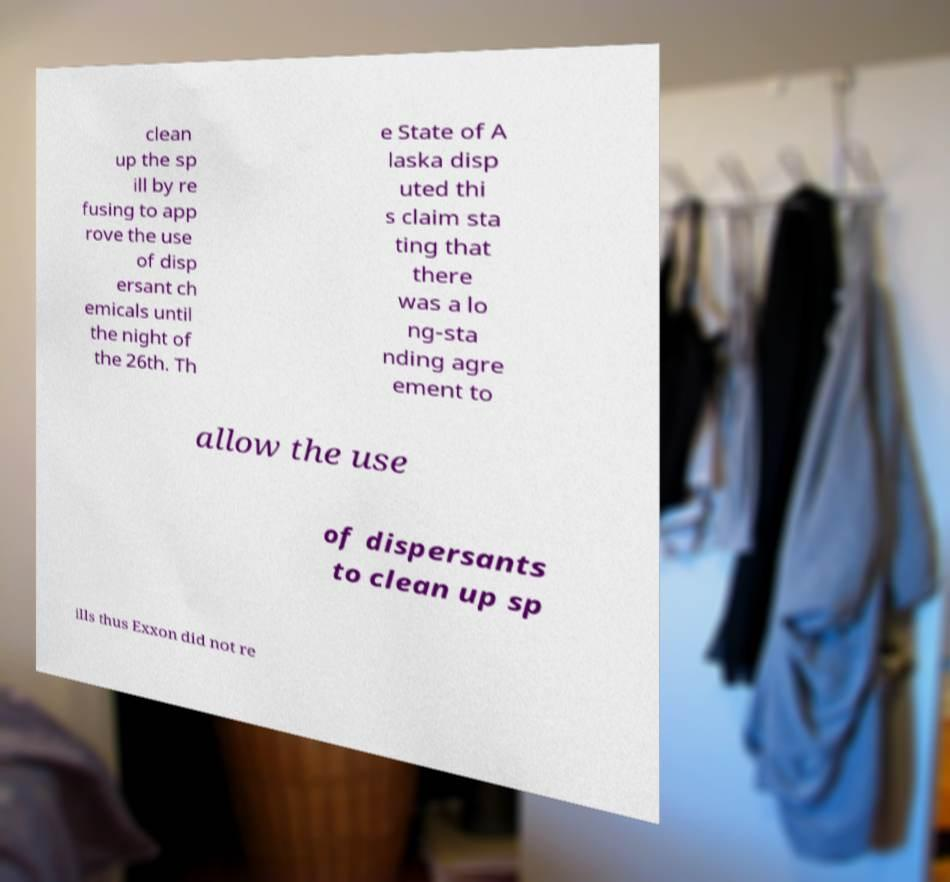There's text embedded in this image that I need extracted. Can you transcribe it verbatim? clean up the sp ill by re fusing to app rove the use of disp ersant ch emicals until the night of the 26th. Th e State of A laska disp uted thi s claim sta ting that there was a lo ng-sta nding agre ement to allow the use of dispersants to clean up sp ills thus Exxon did not re 